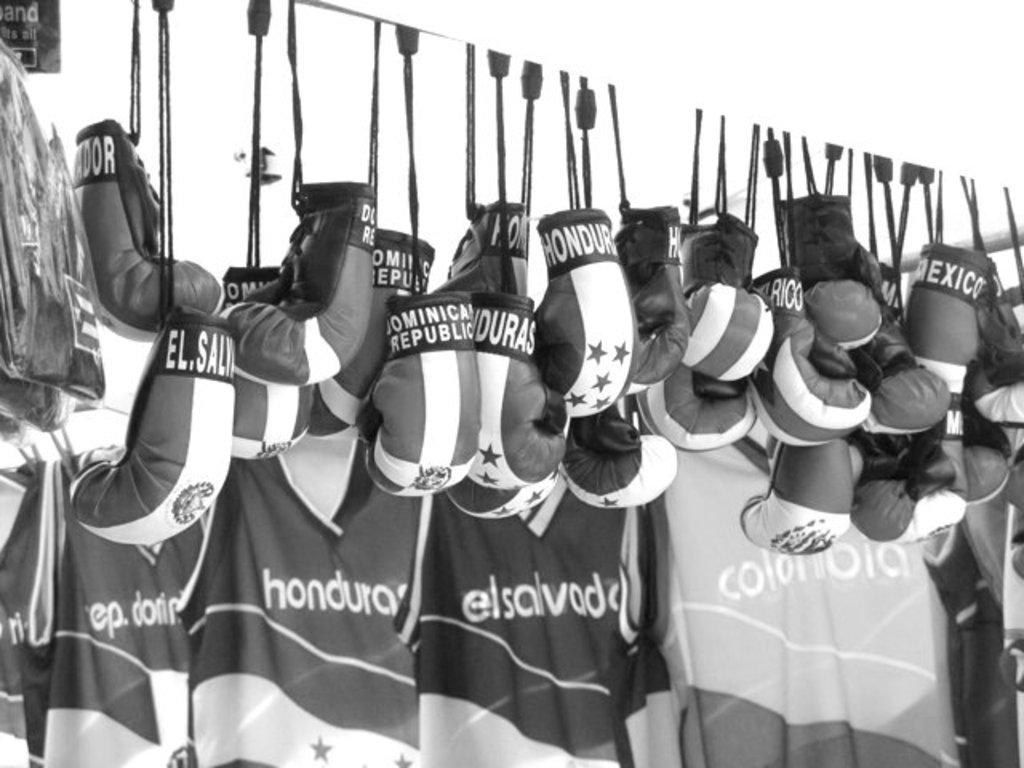<image>
Give a short and clear explanation of the subsequent image. Boxing gloves hanging with Dominican Republic in white letters. 